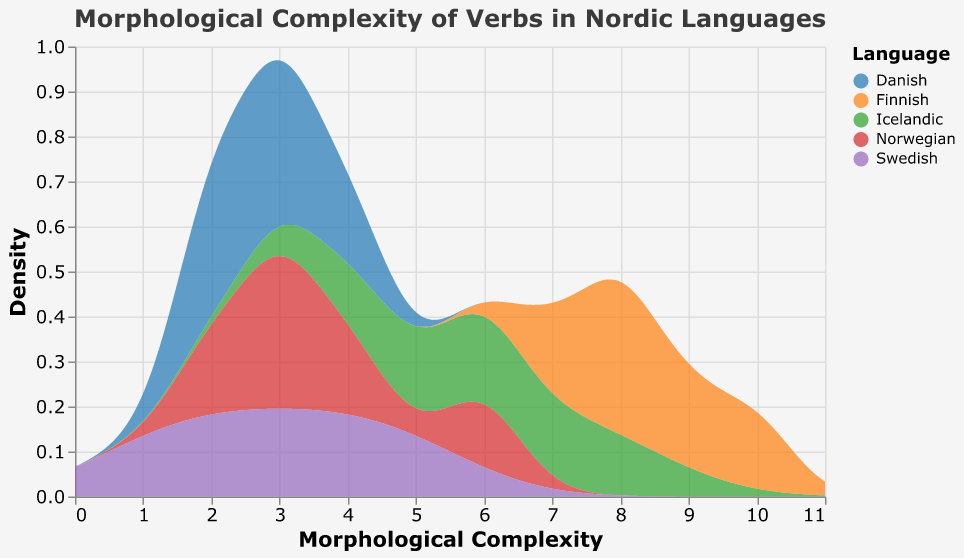What is the peak morphological complexity value for Swedish verbs? The peak value can be identified by looking at the highest point on the density curve for Swedish, which corresponds to when the curve reaches its maximum along the x-axis representing morphological complexity.
Answer: 3 Which language shows the highest peak in morphological complexity? By examining the density plot, the Finnish language will show the highest peak because its density curve reaches the farthest right on the morphological complexity axis.
Answer: Finnish How does the distribution of morphological complexity for Norwegian verbs compare to that for Finnish verbs? To compare, look at the density curves for Norwegian and Finnish languages. Norwegian verbs show a density curve clustered lower on the morphological complexity scale, whereas Finnish verbs have a wider range with a higher complexity peak.
Answer: Norwegian verbs have lower, less varied complexity, while Finnish verbs have higher, more varied complexity What is the average morphological complexity range seen for Icelandic verbs? By observing the Icelandic density curve, its average complexity range can be roughly estimated by pinpointing where the density curve is most concentrated.
Answer: 4 to 8 Which language has the widest spread of morphological complexity values? Check for the language whose density curve stretches the most along the x-axis. Finnish verbs cover a wide range from low to high complexity more than any other language.
Answer: Finnish Do Danish verbs have any morphological complexity values that exceed 5? By reviewing the Danish density curve, which remains left of the 5-mark on the morphological complexity axis, it is clear that all Danish verbs have morphological complexities below 5.
Answer: No In terms of density curves, how do Swedish and Danish verbs' morphological complexities compare? By comparing both Swedish and Danish density curves, observe their position and concentration on the morphological complexity scale. Both curves are similarly limited to lower complexity values, with Swedish having a slightly heavier density around 3.
Answer: Swedish and Danish verbs have lower complexity, concentrated around 3 or less What is the main feature that differentiates the morphological complexity of Finnish verbs from Icelandic verbs? Look for differences in the peaks and spread of the density curves between the two languages. Finnish verbs show a higher peak and wider spread, suggesting higher and more variable morphological complexity compared to Icelandic verbs.
Answer: Finnish verbs have both a higher peak and wider spread Which language demonstrates the lowest maximum morphological complexity, and what is that value? By identifying the maximum x-value where each density curve is present, Norwegian (max ~6) and Danish (max ~4) show lower end values. Danish demonstrates the lowest, peaking around 4.
Answer: Danish, 4 